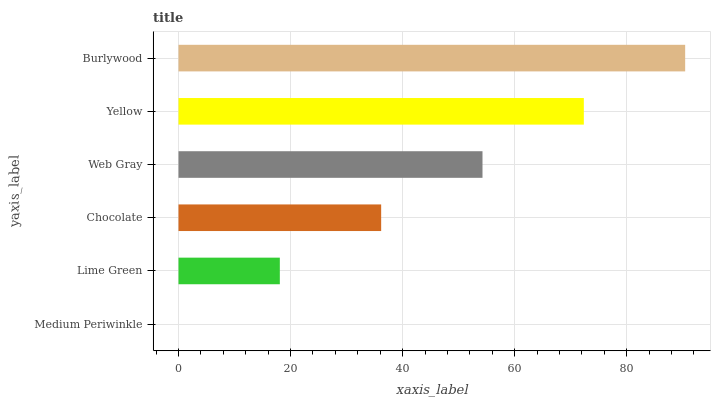Is Medium Periwinkle the minimum?
Answer yes or no. Yes. Is Burlywood the maximum?
Answer yes or no. Yes. Is Lime Green the minimum?
Answer yes or no. No. Is Lime Green the maximum?
Answer yes or no. No. Is Lime Green greater than Medium Periwinkle?
Answer yes or no. Yes. Is Medium Periwinkle less than Lime Green?
Answer yes or no. Yes. Is Medium Periwinkle greater than Lime Green?
Answer yes or no. No. Is Lime Green less than Medium Periwinkle?
Answer yes or no. No. Is Web Gray the high median?
Answer yes or no. Yes. Is Chocolate the low median?
Answer yes or no. Yes. Is Yellow the high median?
Answer yes or no. No. Is Yellow the low median?
Answer yes or no. No. 